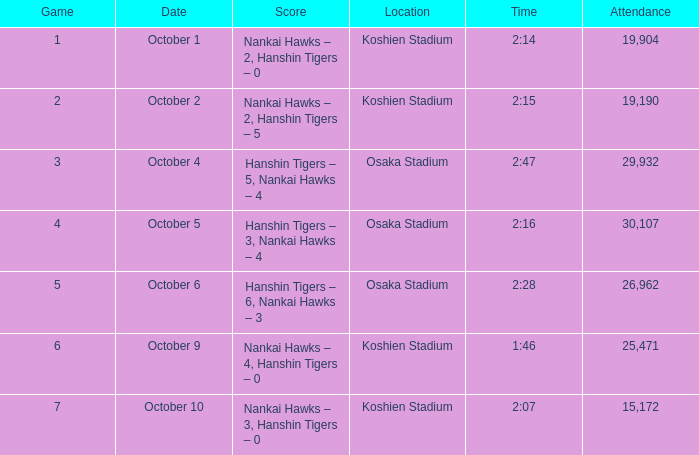How many games have an Attendance of 19,190? 1.0. 